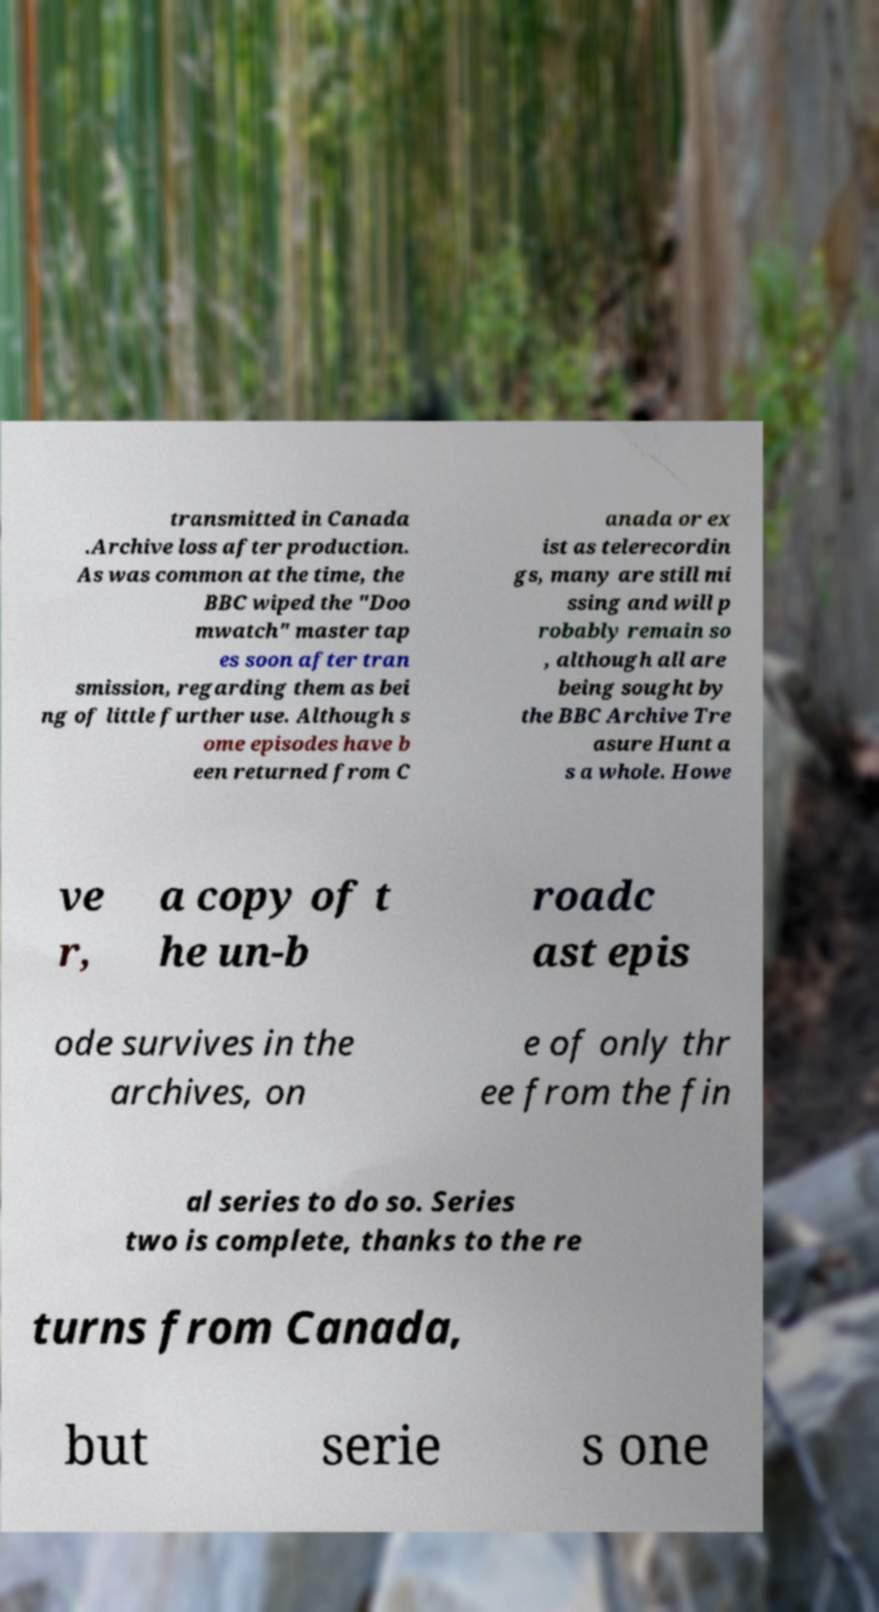Please identify and transcribe the text found in this image. transmitted in Canada .Archive loss after production. As was common at the time, the BBC wiped the "Doo mwatch" master tap es soon after tran smission, regarding them as bei ng of little further use. Although s ome episodes have b een returned from C anada or ex ist as telerecordin gs, many are still mi ssing and will p robably remain so , although all are being sought by the BBC Archive Tre asure Hunt a s a whole. Howe ve r, a copy of t he un-b roadc ast epis ode survives in the archives, on e of only thr ee from the fin al series to do so. Series two is complete, thanks to the re turns from Canada, but serie s one 